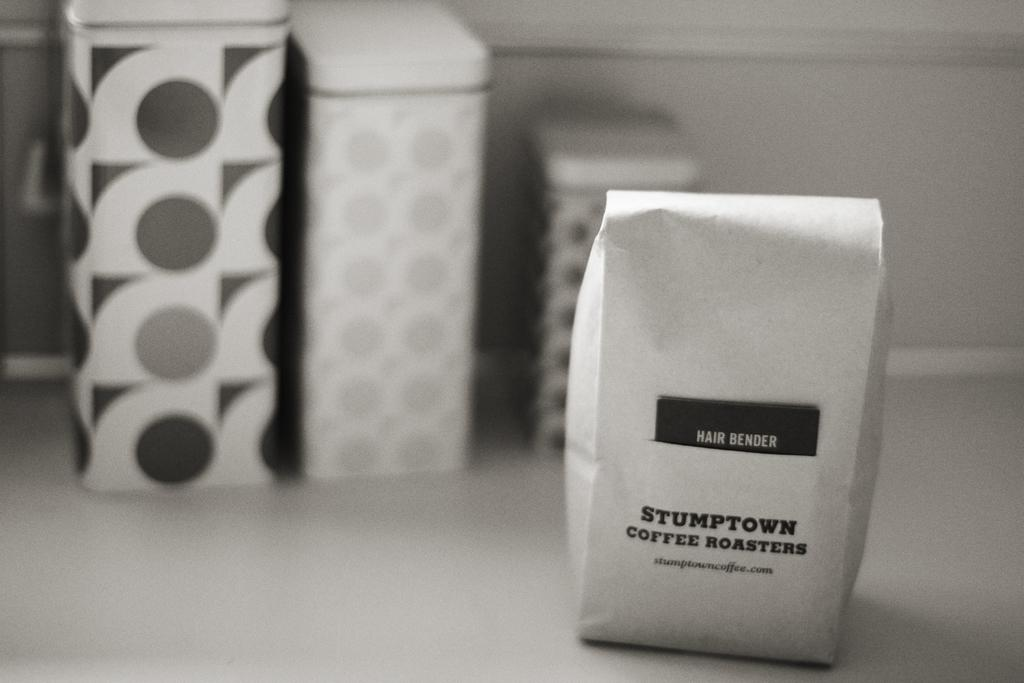<image>
Share a concise interpretation of the image provided. a white bag that says stumptown on it 